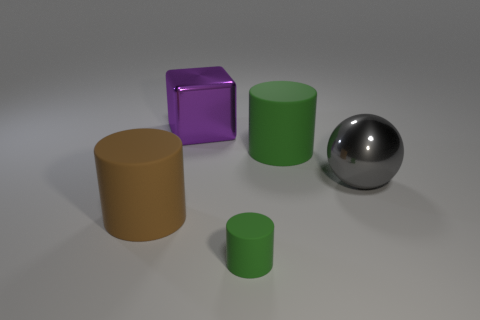What is the purple cube made of?
Your response must be concise. Metal. How many shiny objects are either tiny green cubes or cubes?
Provide a succinct answer. 1. Is the number of green matte cylinders behind the large shiny ball less than the number of cylinders behind the tiny green matte cylinder?
Keep it short and to the point. Yes. There is a object in front of the big rubber object that is left of the tiny green matte cylinder; are there any tiny objects that are in front of it?
Offer a very short reply. No. There is another cylinder that is the same color as the tiny cylinder; what is its material?
Offer a very short reply. Rubber. Is the shape of the large rubber object behind the gray object the same as the rubber thing that is on the left side of the tiny green object?
Ensure brevity in your answer.  Yes. There is a brown cylinder that is the same size as the shiny sphere; what is it made of?
Your answer should be very brief. Rubber. Is the material of the small green cylinder right of the big metal block the same as the gray ball that is behind the tiny green object?
Give a very brief answer. No. There is a brown matte thing that is the same size as the gray object; what is its shape?
Provide a short and direct response. Cylinder. How many other things are there of the same color as the ball?
Your answer should be very brief. 0. 